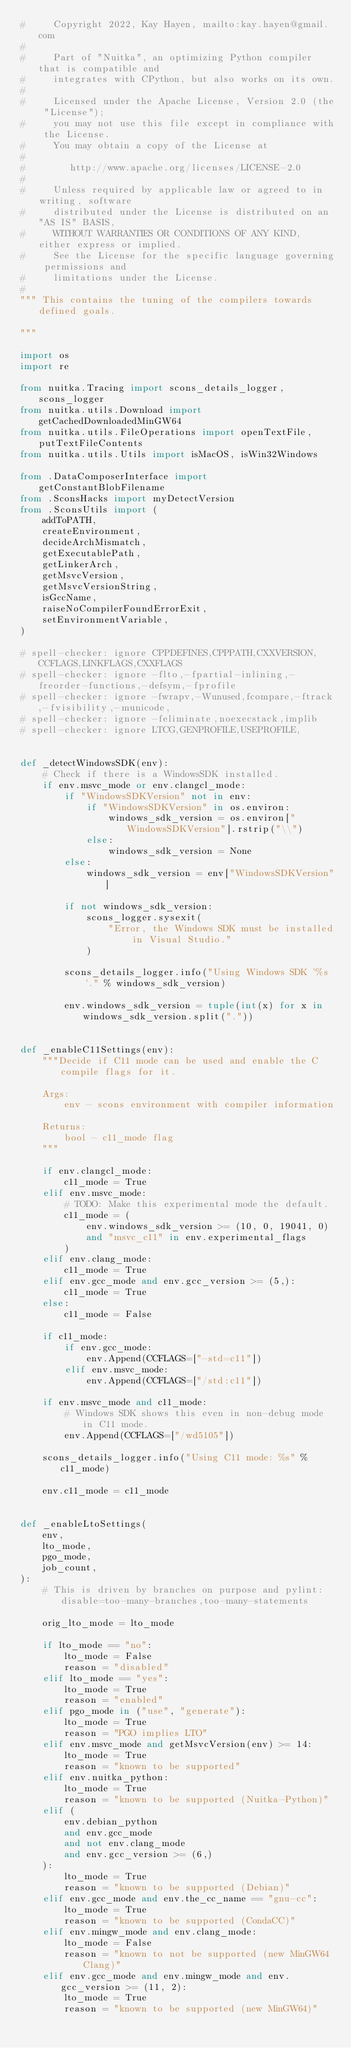Convert code to text. <code><loc_0><loc_0><loc_500><loc_500><_Python_>#     Copyright 2022, Kay Hayen, mailto:kay.hayen@gmail.com
#
#     Part of "Nuitka", an optimizing Python compiler that is compatible and
#     integrates with CPython, but also works on its own.
#
#     Licensed under the Apache License, Version 2.0 (the "License");
#     you may not use this file except in compliance with the License.
#     You may obtain a copy of the License at
#
#        http://www.apache.org/licenses/LICENSE-2.0
#
#     Unless required by applicable law or agreed to in writing, software
#     distributed under the License is distributed on an "AS IS" BASIS,
#     WITHOUT WARRANTIES OR CONDITIONS OF ANY KIND, either express or implied.
#     See the License for the specific language governing permissions and
#     limitations under the License.
#
""" This contains the tuning of the compilers towards defined goals.

"""

import os
import re

from nuitka.Tracing import scons_details_logger, scons_logger
from nuitka.utils.Download import getCachedDownloadedMinGW64
from nuitka.utils.FileOperations import openTextFile, putTextFileContents
from nuitka.utils.Utils import isMacOS, isWin32Windows

from .DataComposerInterface import getConstantBlobFilename
from .SconsHacks import myDetectVersion
from .SconsUtils import (
    addToPATH,
    createEnvironment,
    decideArchMismatch,
    getExecutablePath,
    getLinkerArch,
    getMsvcVersion,
    getMsvcVersionString,
    isGccName,
    raiseNoCompilerFoundErrorExit,
    setEnvironmentVariable,
)

# spell-checker: ignore CPPDEFINES,CPPPATH,CXXVERSION,CCFLAGS,LINKFLAGS,CXXFLAGS
# spell-checker: ignore -flto,-fpartial-inlining,-freorder-functions,-defsym,-fprofile
# spell-checker: ignore -fwrapv,-Wunused,fcompare,-ftrack,-fvisibility,-municode,
# spell-checker: ignore -feliminate,noexecstack,implib
# spell-checker: ignore LTCG,GENPROFILE,USEPROFILE,


def _detectWindowsSDK(env):
    # Check if there is a WindowsSDK installed.
    if env.msvc_mode or env.clangcl_mode:
        if "WindowsSDKVersion" not in env:
            if "WindowsSDKVersion" in os.environ:
                windows_sdk_version = os.environ["WindowsSDKVersion"].rstrip("\\")
            else:
                windows_sdk_version = None
        else:
            windows_sdk_version = env["WindowsSDKVersion"]

        if not windows_sdk_version:
            scons_logger.sysexit(
                "Error, the Windows SDK must be installed in Visual Studio."
            )

        scons_details_logger.info("Using Windows SDK '%s'." % windows_sdk_version)

        env.windows_sdk_version = tuple(int(x) for x in windows_sdk_version.split("."))


def _enableC11Settings(env):
    """Decide if C11 mode can be used and enable the C compile flags for it.

    Args:
        env - scons environment with compiler information

    Returns:
        bool - c11_mode flag
    """

    if env.clangcl_mode:
        c11_mode = True
    elif env.msvc_mode:
        # TODO: Make this experimental mode the default.
        c11_mode = (
            env.windows_sdk_version >= (10, 0, 19041, 0)
            and "msvc_c11" in env.experimental_flags
        )
    elif env.clang_mode:
        c11_mode = True
    elif env.gcc_mode and env.gcc_version >= (5,):
        c11_mode = True
    else:
        c11_mode = False

    if c11_mode:
        if env.gcc_mode:
            env.Append(CCFLAGS=["-std=c11"])
        elif env.msvc_mode:
            env.Append(CCFLAGS=["/std:c11"])

    if env.msvc_mode and c11_mode:
        # Windows SDK shows this even in non-debug mode in C11 mode.
        env.Append(CCFLAGS=["/wd5105"])

    scons_details_logger.info("Using C11 mode: %s" % c11_mode)

    env.c11_mode = c11_mode


def _enableLtoSettings(
    env,
    lto_mode,
    pgo_mode,
    job_count,
):
    # This is driven by branches on purpose and pylint: disable=too-many-branches,too-many-statements

    orig_lto_mode = lto_mode

    if lto_mode == "no":
        lto_mode = False
        reason = "disabled"
    elif lto_mode == "yes":
        lto_mode = True
        reason = "enabled"
    elif pgo_mode in ("use", "generate"):
        lto_mode = True
        reason = "PGO implies LTO"
    elif env.msvc_mode and getMsvcVersion(env) >= 14:
        lto_mode = True
        reason = "known to be supported"
    elif env.nuitka_python:
        lto_mode = True
        reason = "known to be supported (Nuitka-Python)"
    elif (
        env.debian_python
        and env.gcc_mode
        and not env.clang_mode
        and env.gcc_version >= (6,)
    ):
        lto_mode = True
        reason = "known to be supported (Debian)"
    elif env.gcc_mode and env.the_cc_name == "gnu-cc":
        lto_mode = True
        reason = "known to be supported (CondaCC)"
    elif env.mingw_mode and env.clang_mode:
        lto_mode = False
        reason = "known to not be supported (new MinGW64 Clang)"
    elif env.gcc_mode and env.mingw_mode and env.gcc_version >= (11, 2):
        lto_mode = True
        reason = "known to be supported (new MinGW64)"</code> 